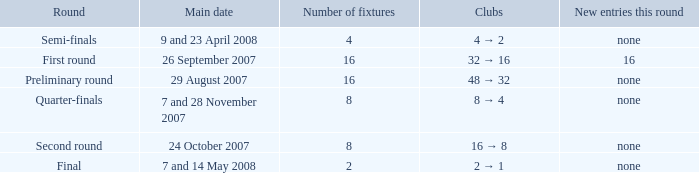What is the Clubs when there are 4 for the number of fixtures? 4 → 2. 